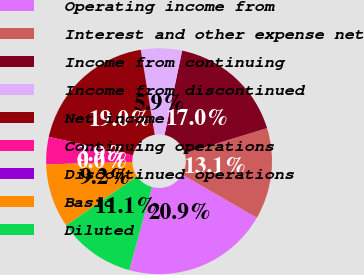Convert chart. <chart><loc_0><loc_0><loc_500><loc_500><pie_chart><fcel>Operating income from<fcel>Interest and other expense net<fcel>Income from continuing<fcel>Income from discontinued<fcel>Net income<fcel>Continuing operations<fcel>Discontinued operations<fcel>Basic<fcel>Diluted<nl><fcel>20.91%<fcel>13.08%<fcel>16.99%<fcel>5.87%<fcel>18.95%<fcel>3.91%<fcel>0.0%<fcel>9.17%<fcel>11.12%<nl></chart> 